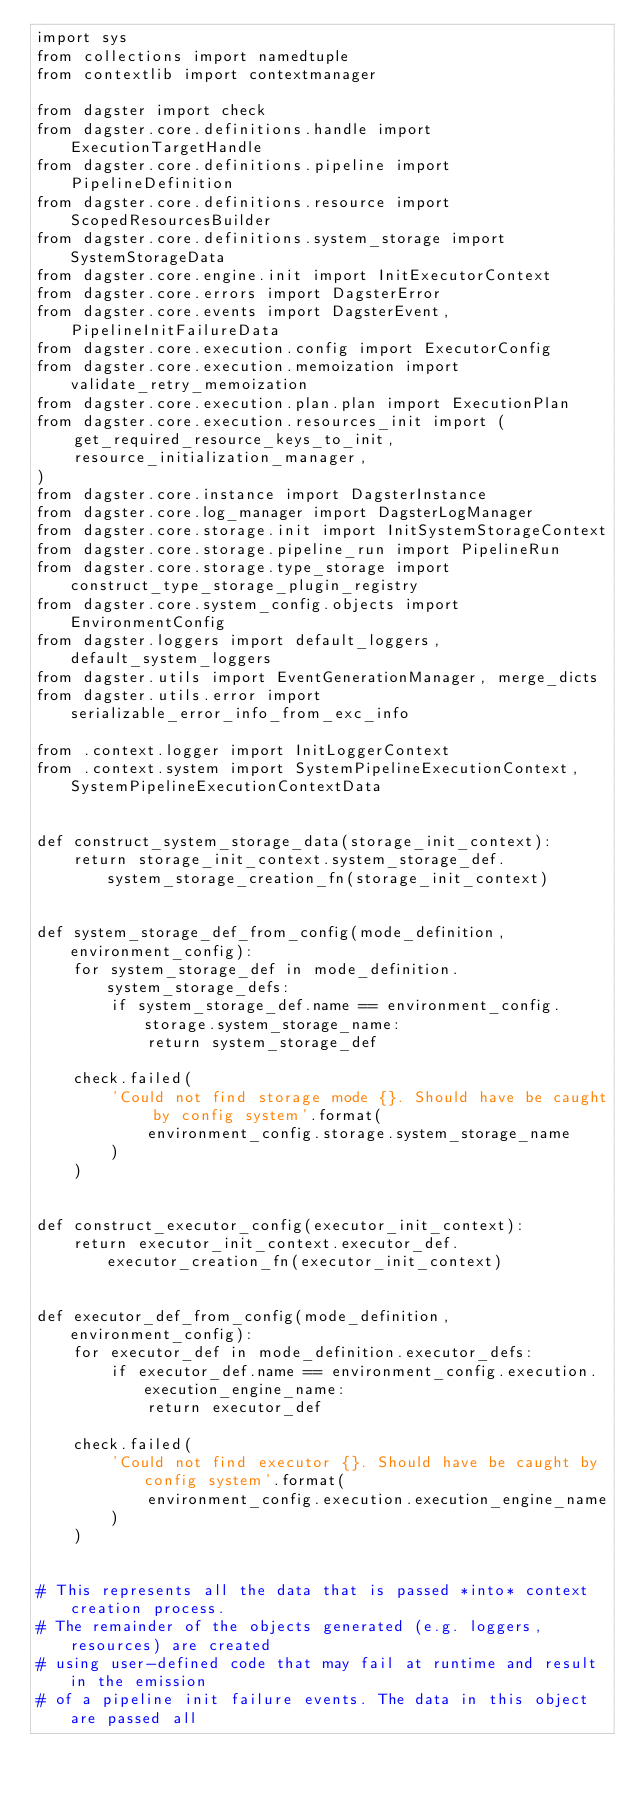Convert code to text. <code><loc_0><loc_0><loc_500><loc_500><_Python_>import sys
from collections import namedtuple
from contextlib import contextmanager

from dagster import check
from dagster.core.definitions.handle import ExecutionTargetHandle
from dagster.core.definitions.pipeline import PipelineDefinition
from dagster.core.definitions.resource import ScopedResourcesBuilder
from dagster.core.definitions.system_storage import SystemStorageData
from dagster.core.engine.init import InitExecutorContext
from dagster.core.errors import DagsterError
from dagster.core.events import DagsterEvent, PipelineInitFailureData
from dagster.core.execution.config import ExecutorConfig
from dagster.core.execution.memoization import validate_retry_memoization
from dagster.core.execution.plan.plan import ExecutionPlan
from dagster.core.execution.resources_init import (
    get_required_resource_keys_to_init,
    resource_initialization_manager,
)
from dagster.core.instance import DagsterInstance
from dagster.core.log_manager import DagsterLogManager
from dagster.core.storage.init import InitSystemStorageContext
from dagster.core.storage.pipeline_run import PipelineRun
from dagster.core.storage.type_storage import construct_type_storage_plugin_registry
from dagster.core.system_config.objects import EnvironmentConfig
from dagster.loggers import default_loggers, default_system_loggers
from dagster.utils import EventGenerationManager, merge_dicts
from dagster.utils.error import serializable_error_info_from_exc_info

from .context.logger import InitLoggerContext
from .context.system import SystemPipelineExecutionContext, SystemPipelineExecutionContextData


def construct_system_storage_data(storage_init_context):
    return storage_init_context.system_storage_def.system_storage_creation_fn(storage_init_context)


def system_storage_def_from_config(mode_definition, environment_config):
    for system_storage_def in mode_definition.system_storage_defs:
        if system_storage_def.name == environment_config.storage.system_storage_name:
            return system_storage_def

    check.failed(
        'Could not find storage mode {}. Should have be caught by config system'.format(
            environment_config.storage.system_storage_name
        )
    )


def construct_executor_config(executor_init_context):
    return executor_init_context.executor_def.executor_creation_fn(executor_init_context)


def executor_def_from_config(mode_definition, environment_config):
    for executor_def in mode_definition.executor_defs:
        if executor_def.name == environment_config.execution.execution_engine_name:
            return executor_def

    check.failed(
        'Could not find executor {}. Should have be caught by config system'.format(
            environment_config.execution.execution_engine_name
        )
    )


# This represents all the data that is passed *into* context creation process.
# The remainder of the objects generated (e.g. loggers, resources) are created
# using user-defined code that may fail at runtime and result in the emission
# of a pipeline init failure events. The data in this object are passed all</code> 